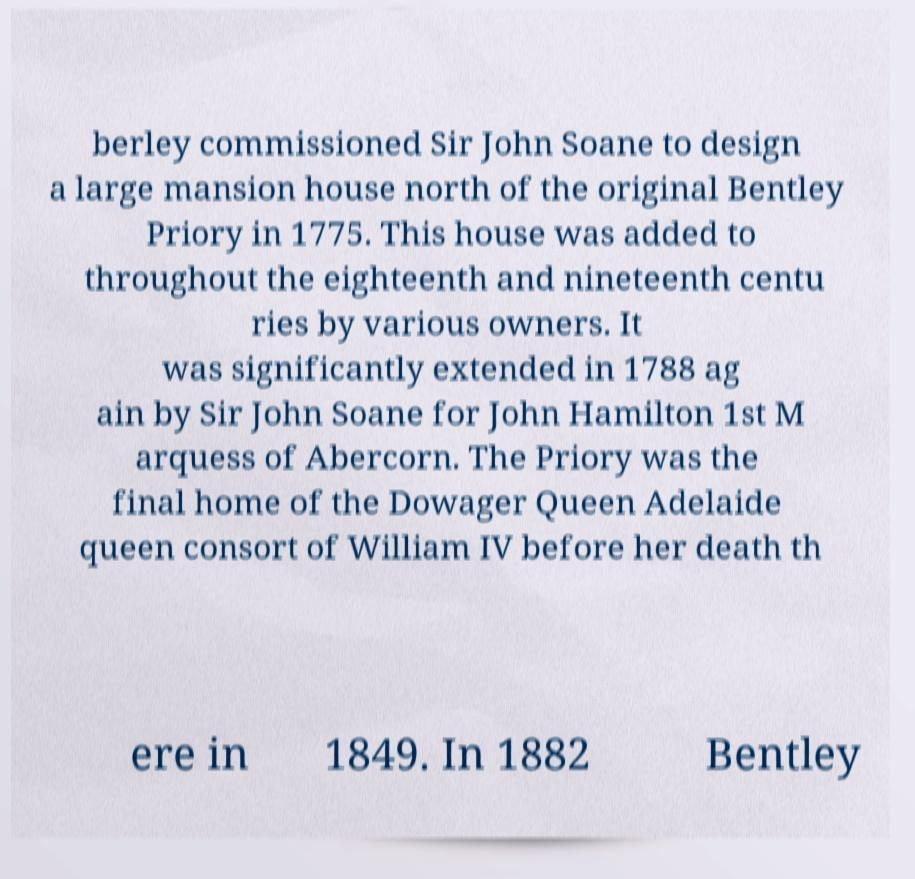Can you accurately transcribe the text from the provided image for me? berley commissioned Sir John Soane to design a large mansion house north of the original Bentley Priory in 1775. This house was added to throughout the eighteenth and nineteenth centu ries by various owners. It was significantly extended in 1788 ag ain by Sir John Soane for John Hamilton 1st M arquess of Abercorn. The Priory was the final home of the Dowager Queen Adelaide queen consort of William IV before her death th ere in 1849. In 1882 Bentley 